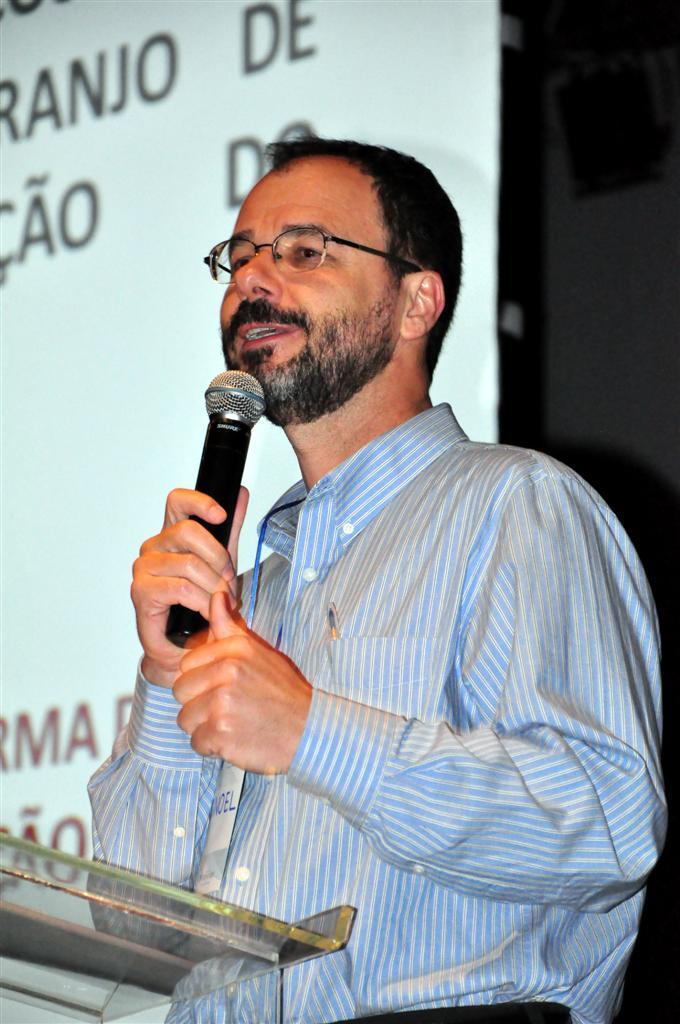What is the main subject of the image? There is a man in the image. What is the man doing in the image? The man is standing and speaking into a microphone. What is the man wearing in the image? The man is wearing a shirt. Can you tell me how many donkeys are present in the image? There are no donkeys present in the image; it features a man standing and speaking into a microphone. 